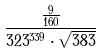Convert formula to latex. <formula><loc_0><loc_0><loc_500><loc_500>\frac { \frac { 9 } { 1 6 0 } } { 3 2 3 ^ { 3 3 9 } \cdot \sqrt { 3 8 3 } }</formula> 